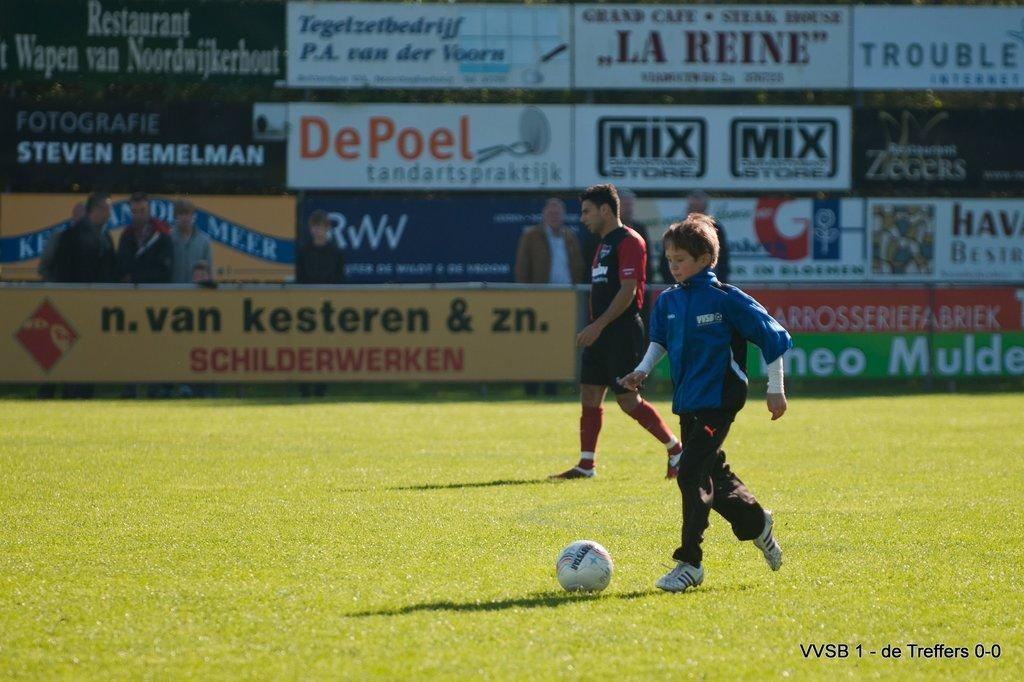What are the two people in the image doing? The two people in the image are playing football. Can you describe the setting of the image? There are spectators in the background of the image. What type of plant is being used as a wheel in the image? There is no plant or wheel present in the image; it features two people playing football and spectators in the background. 